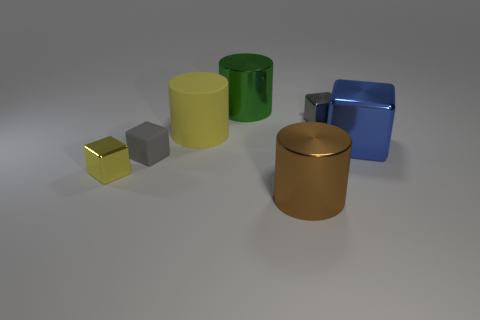Comparing the sizes of the objects, which would be the heaviest and lightest if they were made of the same material? If they were all made of the same material, the large blue cube would likely be the heaviest due to its size, while the small yellow cube would be the lightest. 